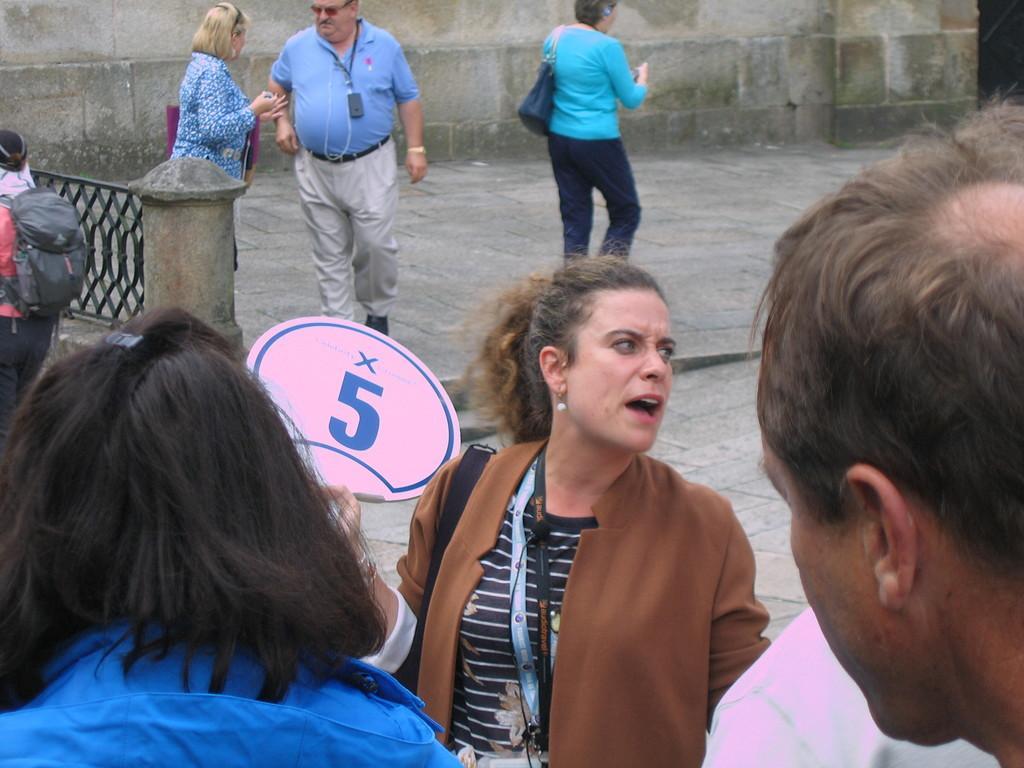In one or two sentences, can you explain what this image depicts? In the image we can see there are people standing on the ground and there is a woman holding placard on which it's written ¨5¨. 